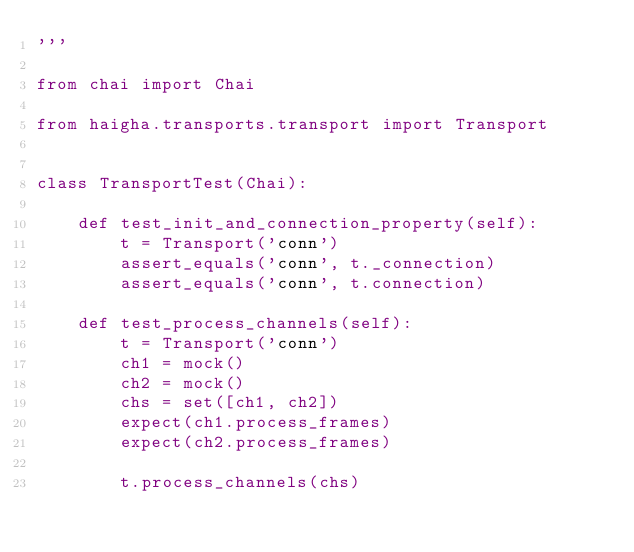Convert code to text. <code><loc_0><loc_0><loc_500><loc_500><_Python_>'''

from chai import Chai

from haigha.transports.transport import Transport


class TransportTest(Chai):

    def test_init_and_connection_property(self):
        t = Transport('conn')
        assert_equals('conn', t._connection)
        assert_equals('conn', t.connection)

    def test_process_channels(self):
        t = Transport('conn')
        ch1 = mock()
        ch2 = mock()
        chs = set([ch1, ch2])
        expect(ch1.process_frames)
        expect(ch2.process_frames)

        t.process_channels(chs)
</code> 